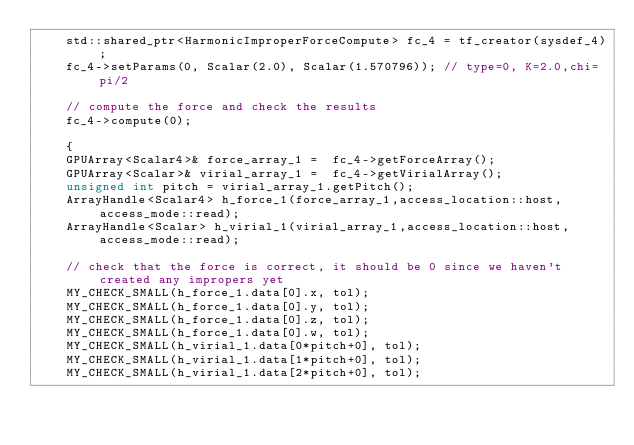Convert code to text. <code><loc_0><loc_0><loc_500><loc_500><_C++_>    std::shared_ptr<HarmonicImproperForceCompute> fc_4 = tf_creator(sysdef_4);
    fc_4->setParams(0, Scalar(2.0), Scalar(1.570796)); // type=0, K=2.0,chi=pi/2

    // compute the force and check the results
    fc_4->compute(0);

    {
    GPUArray<Scalar4>& force_array_1 =  fc_4->getForceArray();
    GPUArray<Scalar>& virial_array_1 =  fc_4->getVirialArray();
    unsigned int pitch = virial_array_1.getPitch();
    ArrayHandle<Scalar4> h_force_1(force_array_1,access_location::host,access_mode::read);
    ArrayHandle<Scalar> h_virial_1(virial_array_1,access_location::host,access_mode::read);

    // check that the force is correct, it should be 0 since we haven't created any impropers yet
    MY_CHECK_SMALL(h_force_1.data[0].x, tol);
    MY_CHECK_SMALL(h_force_1.data[0].y, tol);
    MY_CHECK_SMALL(h_force_1.data[0].z, tol);
    MY_CHECK_SMALL(h_force_1.data[0].w, tol);
    MY_CHECK_SMALL(h_virial_1.data[0*pitch+0], tol);
    MY_CHECK_SMALL(h_virial_1.data[1*pitch+0], tol);
    MY_CHECK_SMALL(h_virial_1.data[2*pitch+0], tol);</code> 